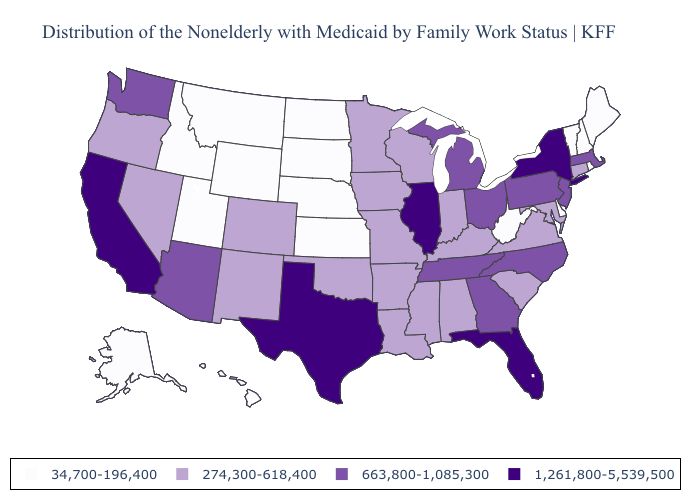Does South Dakota have the same value as Rhode Island?
Quick response, please. Yes. Name the states that have a value in the range 274,300-618,400?
Short answer required. Alabama, Arkansas, Colorado, Connecticut, Indiana, Iowa, Kentucky, Louisiana, Maryland, Minnesota, Mississippi, Missouri, Nevada, New Mexico, Oklahoma, Oregon, South Carolina, Virginia, Wisconsin. Does Missouri have the lowest value in the USA?
Write a very short answer. No. What is the value of Colorado?
Answer briefly. 274,300-618,400. What is the highest value in the South ?
Be succinct. 1,261,800-5,539,500. Which states have the lowest value in the Northeast?
Write a very short answer. Maine, New Hampshire, Rhode Island, Vermont. Among the states that border Tennessee , which have the lowest value?
Keep it brief. Alabama, Arkansas, Kentucky, Mississippi, Missouri, Virginia. Name the states that have a value in the range 274,300-618,400?
Quick response, please. Alabama, Arkansas, Colorado, Connecticut, Indiana, Iowa, Kentucky, Louisiana, Maryland, Minnesota, Mississippi, Missouri, Nevada, New Mexico, Oklahoma, Oregon, South Carolina, Virginia, Wisconsin. Which states have the lowest value in the Northeast?
Short answer required. Maine, New Hampshire, Rhode Island, Vermont. What is the lowest value in the USA?
Keep it brief. 34,700-196,400. What is the highest value in states that border Minnesota?
Write a very short answer. 274,300-618,400. Does Iowa have the highest value in the MidWest?
Answer briefly. No. Does the map have missing data?
Be succinct. No. What is the lowest value in the USA?
Concise answer only. 34,700-196,400. What is the lowest value in the USA?
Short answer required. 34,700-196,400. 